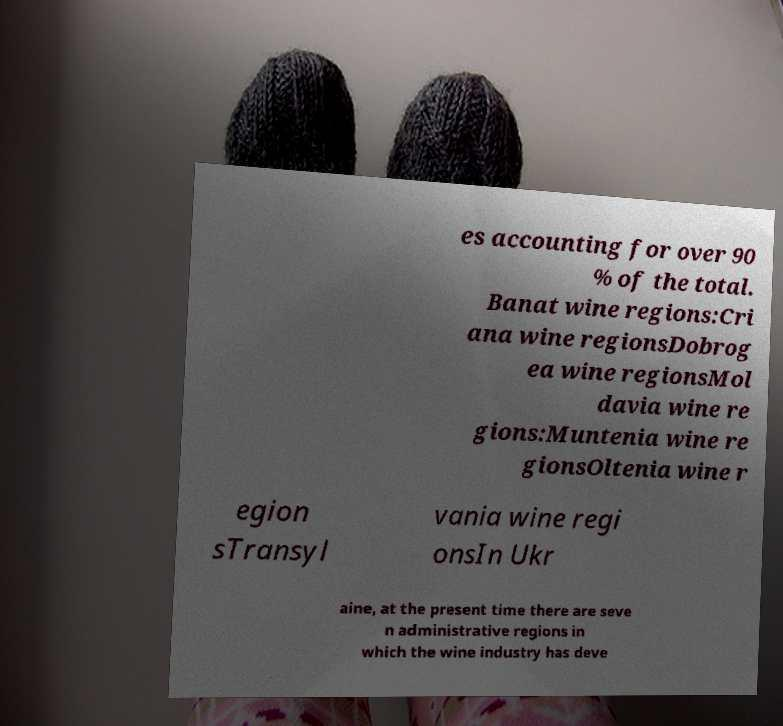Can you accurately transcribe the text from the provided image for me? es accounting for over 90 % of the total. Banat wine regions:Cri ana wine regionsDobrog ea wine regionsMol davia wine re gions:Muntenia wine re gionsOltenia wine r egion sTransyl vania wine regi onsIn Ukr aine, at the present time there are seve n administrative regions in which the wine industry has deve 